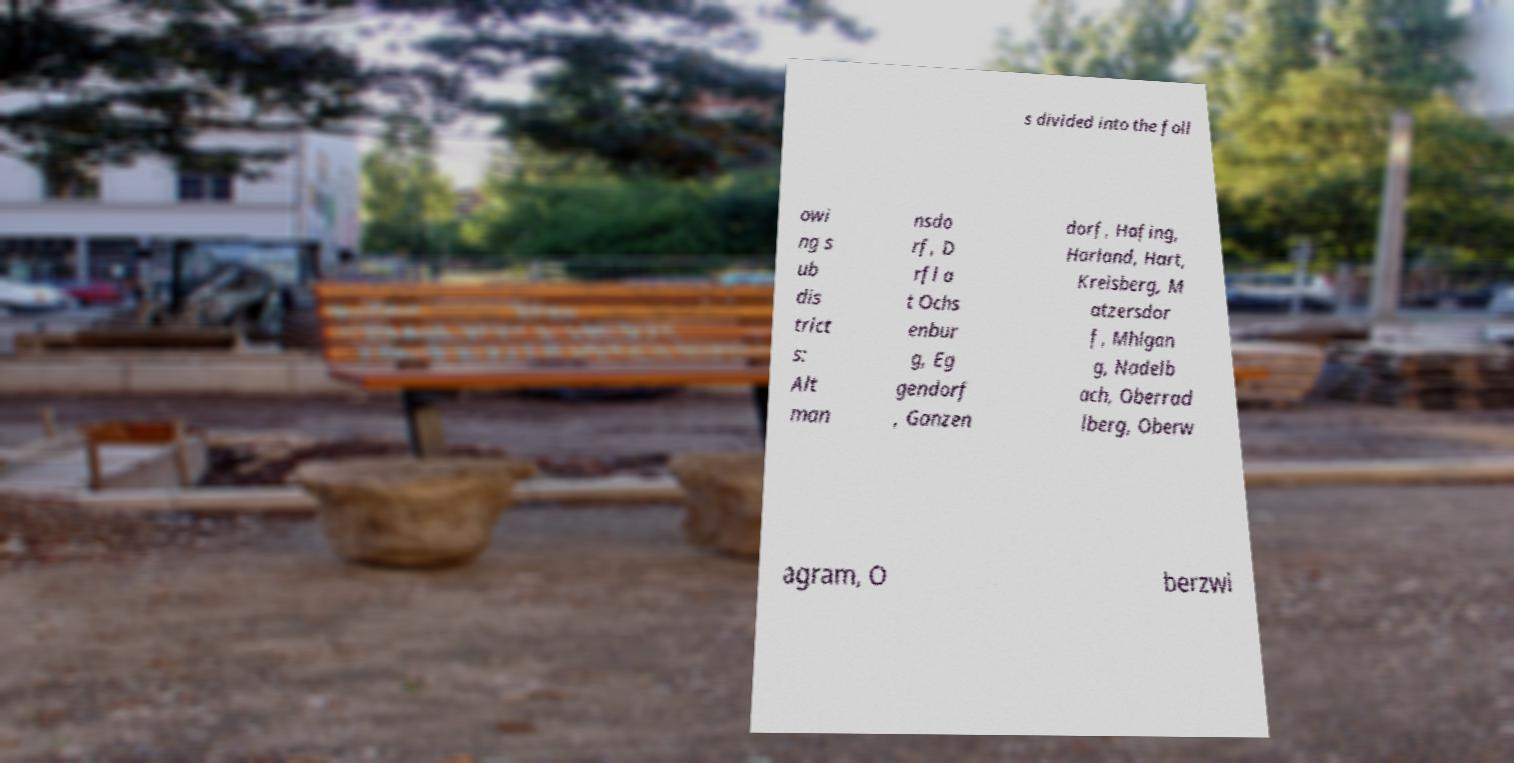Could you extract and type out the text from this image? s divided into the foll owi ng s ub dis trict s: Alt man nsdo rf, D rfl a t Ochs enbur g, Eg gendorf , Ganzen dorf, Hafing, Harland, Hart, Kreisberg, M atzersdor f, Mhlgan g, Nadelb ach, Oberrad lberg, Oberw agram, O berzwi 